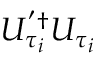Convert formula to latex. <formula><loc_0><loc_0><loc_500><loc_500>U _ { \tau _ { i } } ^ { ^ { \prime } \dagger } U _ { \tau _ { i } }</formula> 